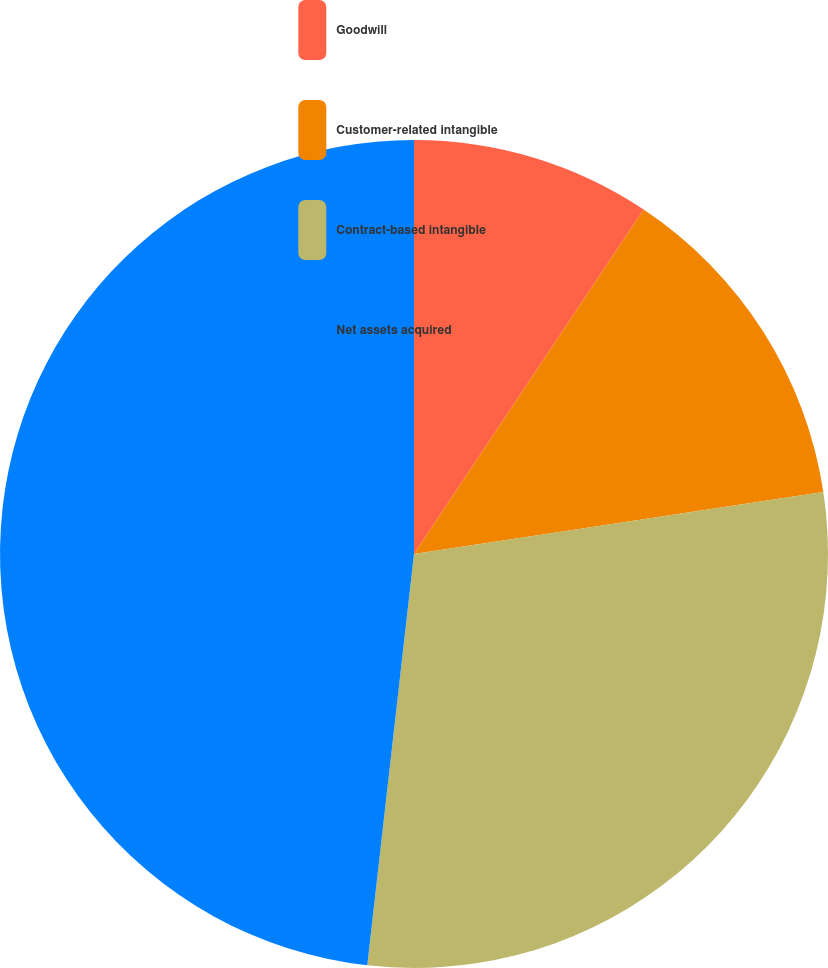<chart> <loc_0><loc_0><loc_500><loc_500><pie_chart><fcel>Goodwill<fcel>Customer-related intangible<fcel>Contract-based intangible<fcel>Net assets acquired<nl><fcel>9.36%<fcel>13.25%<fcel>29.19%<fcel>48.2%<nl></chart> 